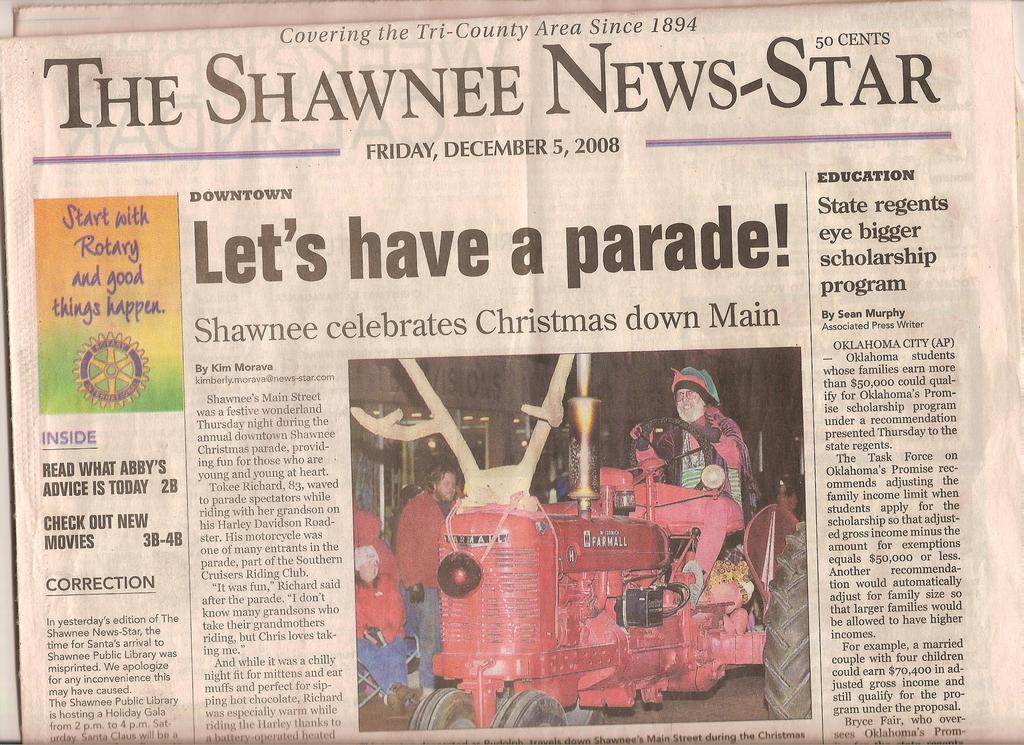<image>
Create a compact narrative representing the image presented. The Shawnee News Star showing an article about the Shawnee Christmas celebration. 